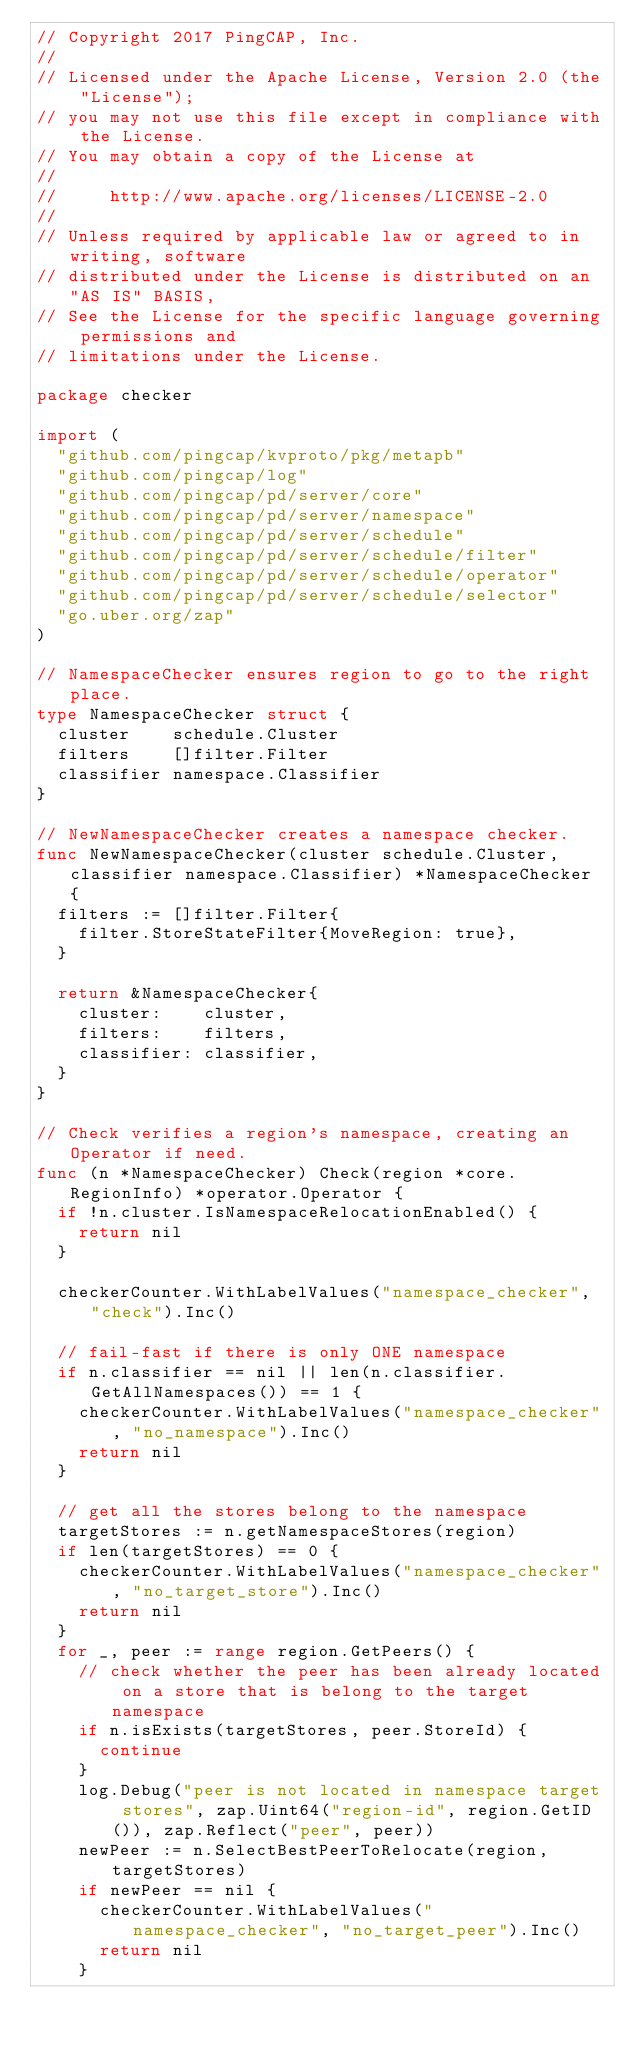<code> <loc_0><loc_0><loc_500><loc_500><_Go_>// Copyright 2017 PingCAP, Inc.
//
// Licensed under the Apache License, Version 2.0 (the "License");
// you may not use this file except in compliance with the License.
// You may obtain a copy of the License at
//
//     http://www.apache.org/licenses/LICENSE-2.0
//
// Unless required by applicable law or agreed to in writing, software
// distributed under the License is distributed on an "AS IS" BASIS,
// See the License for the specific language governing permissions and
// limitations under the License.

package checker

import (
	"github.com/pingcap/kvproto/pkg/metapb"
	"github.com/pingcap/log"
	"github.com/pingcap/pd/server/core"
	"github.com/pingcap/pd/server/namespace"
	"github.com/pingcap/pd/server/schedule"
	"github.com/pingcap/pd/server/schedule/filter"
	"github.com/pingcap/pd/server/schedule/operator"
	"github.com/pingcap/pd/server/schedule/selector"
	"go.uber.org/zap"
)

// NamespaceChecker ensures region to go to the right place.
type NamespaceChecker struct {
	cluster    schedule.Cluster
	filters    []filter.Filter
	classifier namespace.Classifier
}

// NewNamespaceChecker creates a namespace checker.
func NewNamespaceChecker(cluster schedule.Cluster, classifier namespace.Classifier) *NamespaceChecker {
	filters := []filter.Filter{
		filter.StoreStateFilter{MoveRegion: true},
	}

	return &NamespaceChecker{
		cluster:    cluster,
		filters:    filters,
		classifier: classifier,
	}
}

// Check verifies a region's namespace, creating an Operator if need.
func (n *NamespaceChecker) Check(region *core.RegionInfo) *operator.Operator {
	if !n.cluster.IsNamespaceRelocationEnabled() {
		return nil
	}

	checkerCounter.WithLabelValues("namespace_checker", "check").Inc()

	// fail-fast if there is only ONE namespace
	if n.classifier == nil || len(n.classifier.GetAllNamespaces()) == 1 {
		checkerCounter.WithLabelValues("namespace_checker", "no_namespace").Inc()
		return nil
	}

	// get all the stores belong to the namespace
	targetStores := n.getNamespaceStores(region)
	if len(targetStores) == 0 {
		checkerCounter.WithLabelValues("namespace_checker", "no_target_store").Inc()
		return nil
	}
	for _, peer := range region.GetPeers() {
		// check whether the peer has been already located on a store that is belong to the target namespace
		if n.isExists(targetStores, peer.StoreId) {
			continue
		}
		log.Debug("peer is not located in namespace target stores", zap.Uint64("region-id", region.GetID()), zap.Reflect("peer", peer))
		newPeer := n.SelectBestPeerToRelocate(region, targetStores)
		if newPeer == nil {
			checkerCounter.WithLabelValues("namespace_checker", "no_target_peer").Inc()
			return nil
		}</code> 